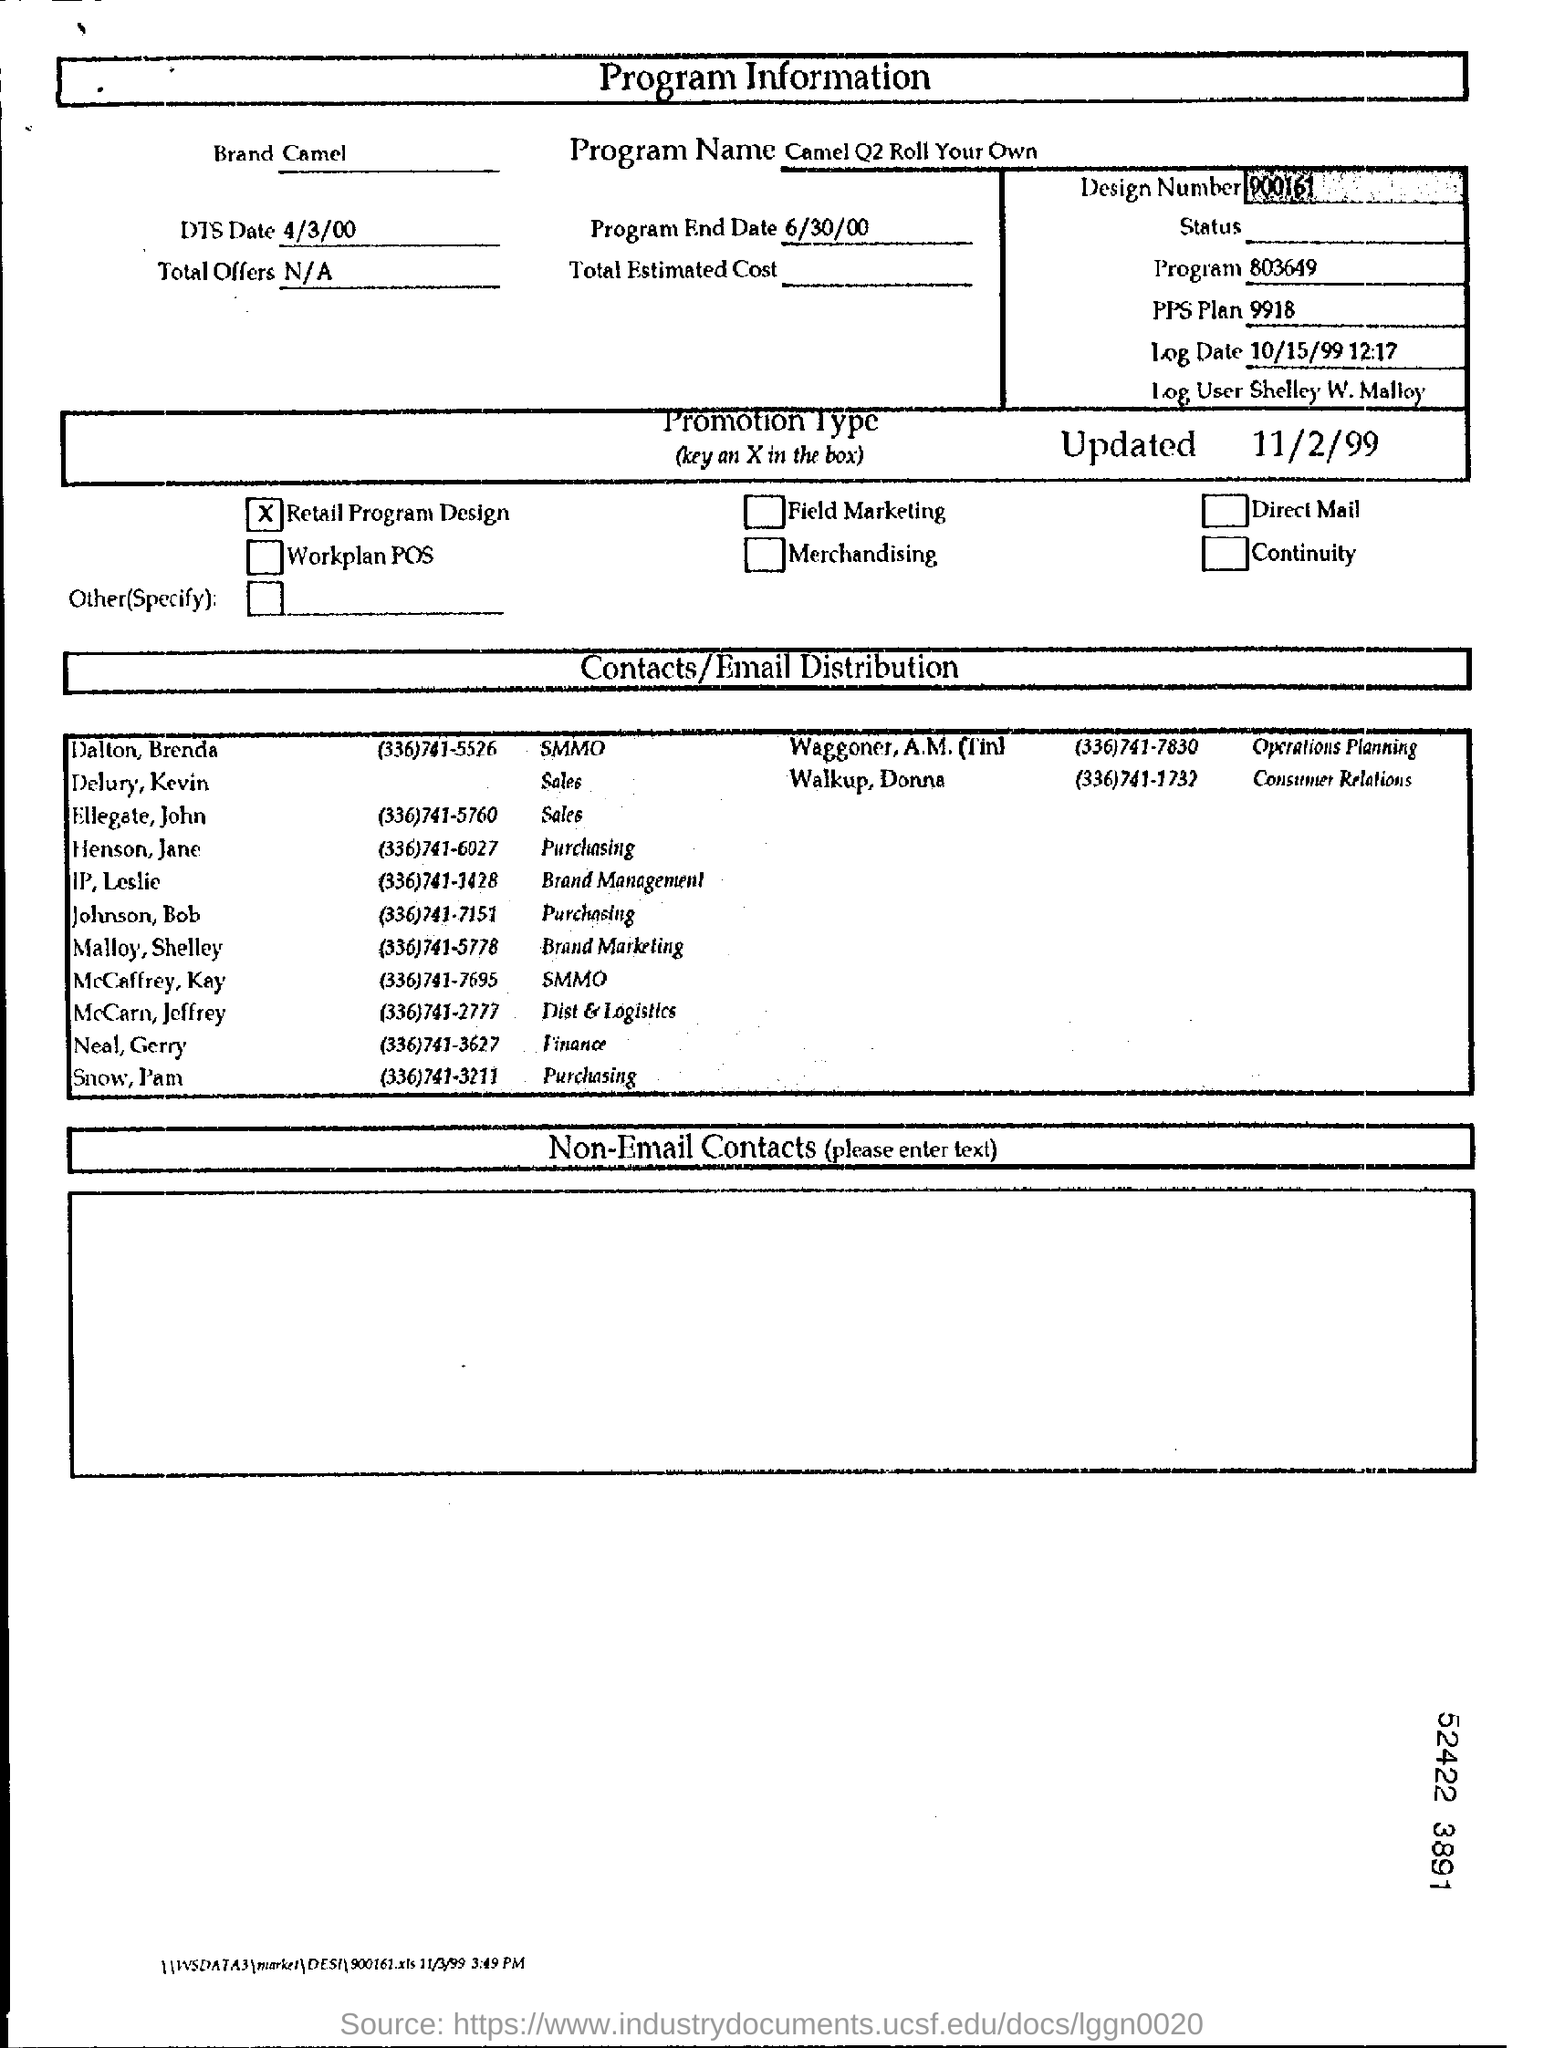Highlight a few significant elements in this photo. The total offer on the page is not available. The program's end date is June 30, 2000. The page is dedicated to providing information on a program. The user who is currently logged in to this page is Shelley W. Malloy. 